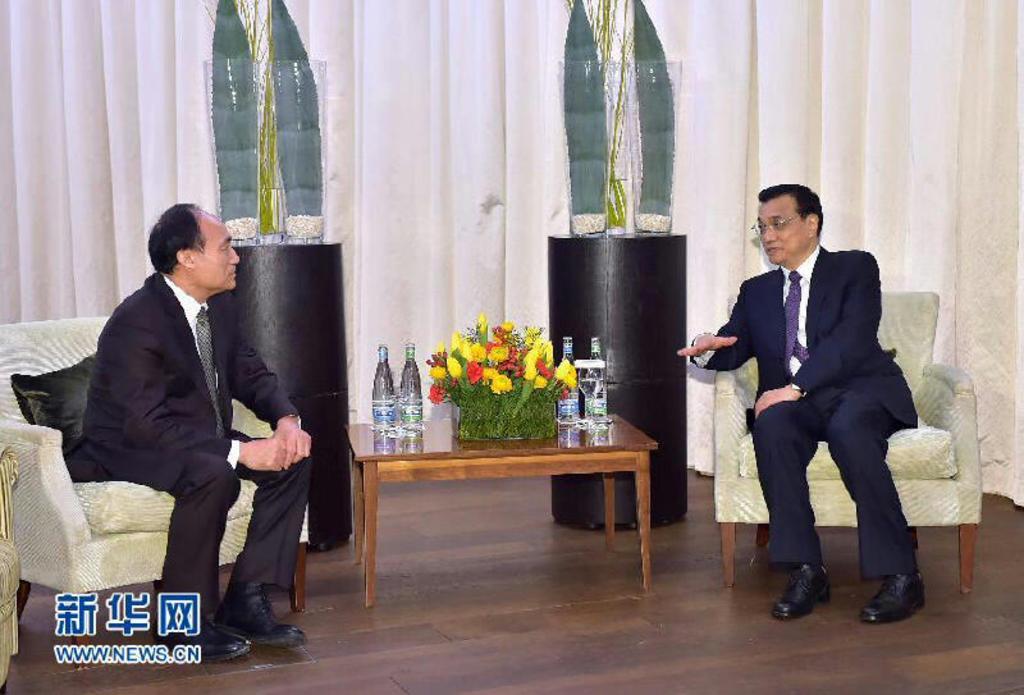How would you summarize this image in a sentence or two? In this image we can see two men sitting on their respective chairs, there is a table between them and on the table there are some bottles a flower vase and in the background there are black color objects and curtains. 